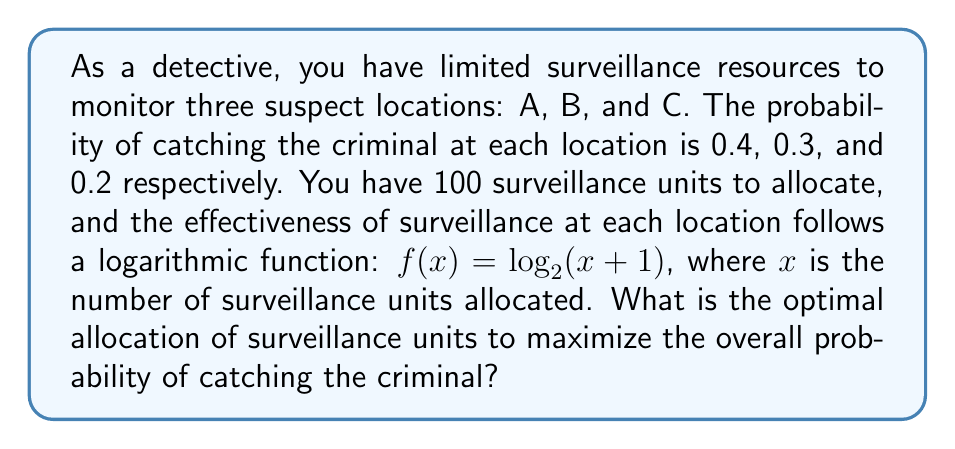Give your solution to this math problem. To solve this problem, we'll use the method of Lagrange multipliers, which is often employed in game theory for resource allocation problems.

1) Let $x$, $y$, and $z$ be the number of surveillance units allocated to locations A, B, and C respectively.

2) The objective function to maximize is:
   $$F(x,y,z) = 0.4\log_2(x+1) + 0.3\log_2(y+1) + 0.2\log_2(z+1)$$

3) The constraint is:
   $$x + y + z = 100$$

4) Form the Lagrangian:
   $$L(x,y,z,\lambda) = 0.4\log_2(x+1) + 0.3\log_2(y+1) + 0.2\log_2(z+1) - \lambda(x+y+z-100)$$

5) Take partial derivatives and set them to zero:
   $$\frac{\partial L}{\partial x} = \frac{0.4}{(x+1)\ln 2} - \lambda = 0$$
   $$\frac{\partial L}{\partial y} = \frac{0.3}{(y+1)\ln 2} - \lambda = 0$$
   $$\frac{\partial L}{\partial z} = \frac{0.2}{(z+1)\ln 2} - \lambda = 0$$
   $$\frac{\partial L}{\partial \lambda} = x + y + z - 100 = 0$$

6) From these equations, we can derive:
   $$\frac{0.4}{x+1} = \frac{0.3}{y+1} = \frac{0.2}{z+1}$$

7) Let $k = \frac{0.4}{x+1}$. Then:
   $$x = \frac{0.4}{k} - 1$$
   $$y = \frac{0.3}{k} - 1$$
   $$z = \frac{0.2}{k} - 1$$

8) Substitute into the constraint equation:
   $$(\frac{0.4}{k} - 1) + (\frac{0.3}{k} - 1) + (\frac{0.2}{k} - 1) = 100$$
   $$\frac{0.9}{k} - 3 = 100$$
   $$\frac{0.9}{k} = 103$$
   $$k = \frac{0.9}{103} \approx 0.00874$$

9) Now we can solve for x, y, and z:
   $$x = \frac{0.4}{0.00874} - 1 \approx 44.76$$
   $$y = \frac{0.3}{0.00874} - 1 \approx 33.32$$
   $$z = \frac{0.2}{0.00874} - 1 \approx 21.92$$

10) Rounding to the nearest whole number (as we can't allocate partial surveillance units):
    x = 45, y = 33, z = 22
Answer: The optimal allocation of surveillance units is 45 units to location A, 33 units to location B, and 22 units to location C. 